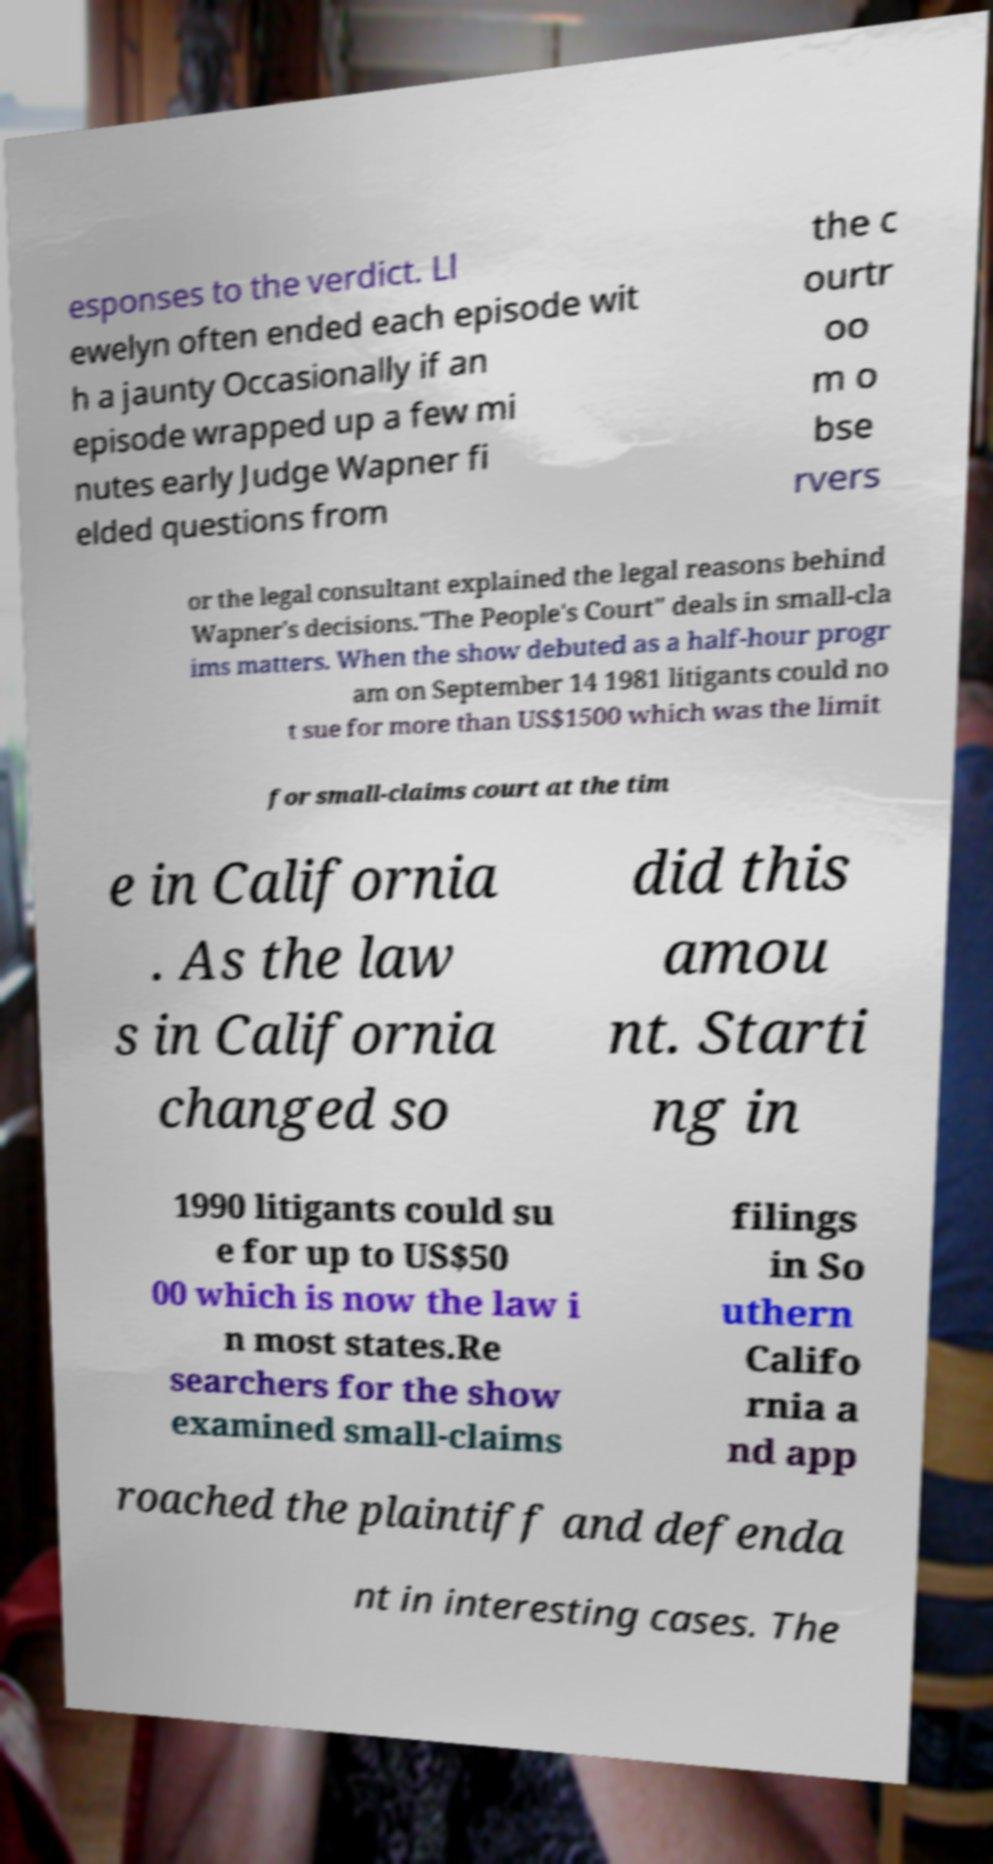There's text embedded in this image that I need extracted. Can you transcribe it verbatim? esponses to the verdict. Ll ewelyn often ended each episode wit h a jaunty Occasionally if an episode wrapped up a few mi nutes early Judge Wapner fi elded questions from the c ourtr oo m o bse rvers or the legal consultant explained the legal reasons behind Wapner's decisions."The People's Court" deals in small-cla ims matters. When the show debuted as a half-hour progr am on September 14 1981 litigants could no t sue for more than US$1500 which was the limit for small-claims court at the tim e in California . As the law s in California changed so did this amou nt. Starti ng in 1990 litigants could su e for up to US$50 00 which is now the law i n most states.Re searchers for the show examined small-claims filings in So uthern Califo rnia a nd app roached the plaintiff and defenda nt in interesting cases. The 